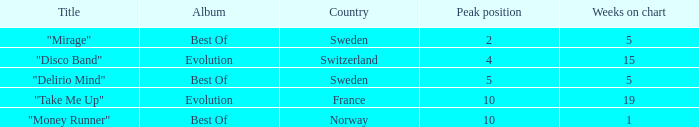What is the title of the song that had a highest rank of 10 and spent under 19 weeks on the chart? "Money Runner". 